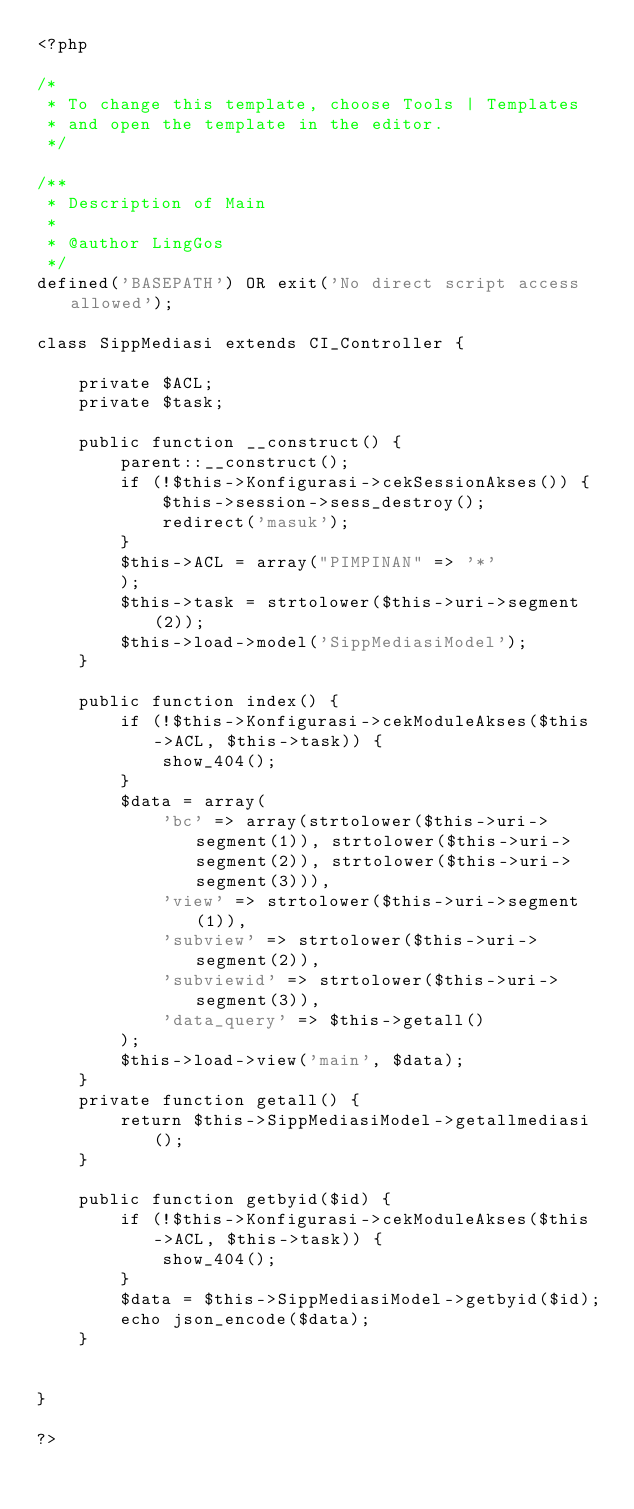<code> <loc_0><loc_0><loc_500><loc_500><_PHP_><?php

/*
 * To change this template, choose Tools | Templates
 * and open the template in the editor.
 */

/**
 * Description of Main
 *
 * @author LingGos
 */
defined('BASEPATH') OR exit('No direct script access allowed');

class SippMediasi extends CI_Controller {

    private $ACL;
    private $task;

    public function __construct() {
        parent::__construct();
        if (!$this->Konfigurasi->cekSessionAkses()) {
            $this->session->sess_destroy();
            redirect('masuk');
        }
        $this->ACL = array("PIMPINAN" => '*'
        );
        $this->task = strtolower($this->uri->segment(2));
        $this->load->model('SippMediasiModel');
    }

    public function index() {
        if (!$this->Konfigurasi->cekModuleAkses($this->ACL, $this->task)) {
            show_404();
        }
        $data = array(
            'bc' => array(strtolower($this->uri->segment(1)), strtolower($this->uri->segment(2)), strtolower($this->uri->segment(3))),
            'view' => strtolower($this->uri->segment(1)),
            'subview' => strtolower($this->uri->segment(2)),
            'subviewid' => strtolower($this->uri->segment(3)),
            'data_query' => $this->getall()
        );
        $this->load->view('main', $data);
    }
    private function getall() {
        return $this->SippMediasiModel->getallmediasi();   
    }
    
    public function getbyid($id) {
        if (!$this->Konfigurasi->cekModuleAkses($this->ACL, $this->task)) {
            show_404();
        }
        $data = $this->SippMediasiModel->getbyid($id);
        echo json_encode($data);
    }

    
}

?>
</code> 